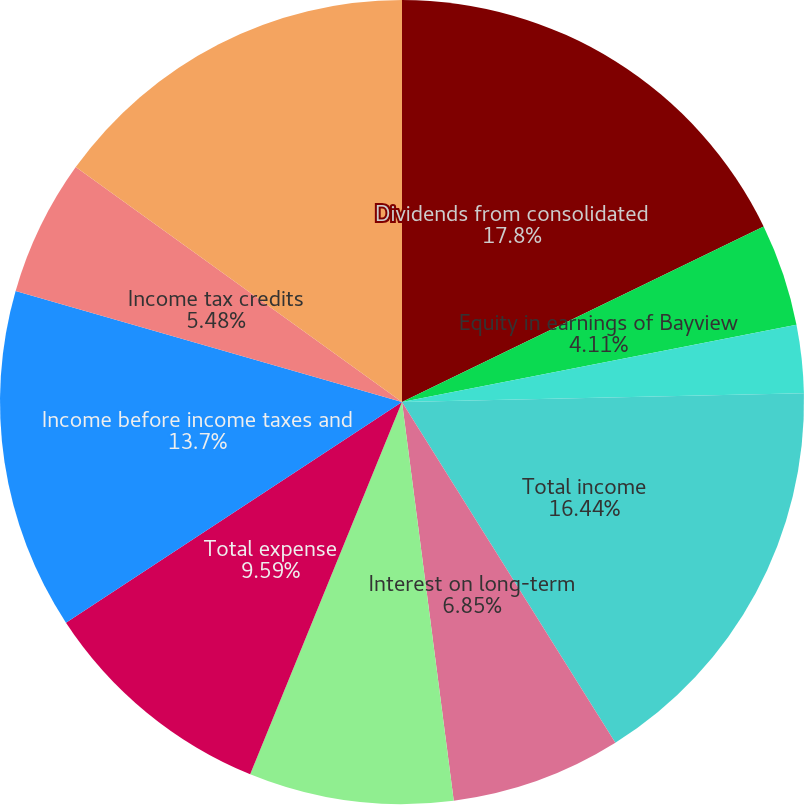Convert chart. <chart><loc_0><loc_0><loc_500><loc_500><pie_chart><fcel>Dividends from consolidated<fcel>Equity in earnings of Bayview<fcel>Other income<fcel>Total income<fcel>Interest on long-term<fcel>Other expense<fcel>Total expense<fcel>Income before income taxes and<fcel>Income tax credits<fcel>Income before equity in<nl><fcel>17.81%<fcel>4.11%<fcel>2.74%<fcel>16.44%<fcel>6.85%<fcel>8.22%<fcel>9.59%<fcel>13.7%<fcel>5.48%<fcel>15.07%<nl></chart> 